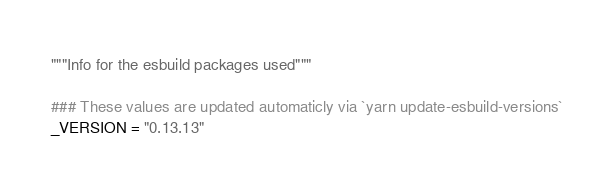Convert code to text. <code><loc_0><loc_0><loc_500><loc_500><_Python_>"""Info for the esbuild packages used"""

### These values are updated automaticly via `yarn update-esbuild-versions`
_VERSION = "0.13.13"</code> 